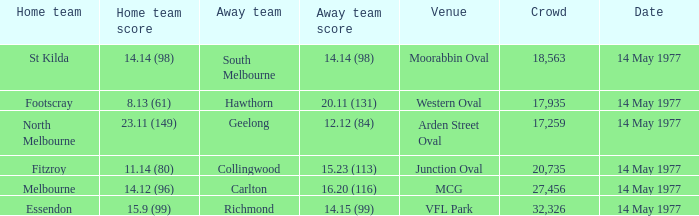I want to know the home team score of the away team of richmond that has a crowd more than 20,735 15.9 (99). 